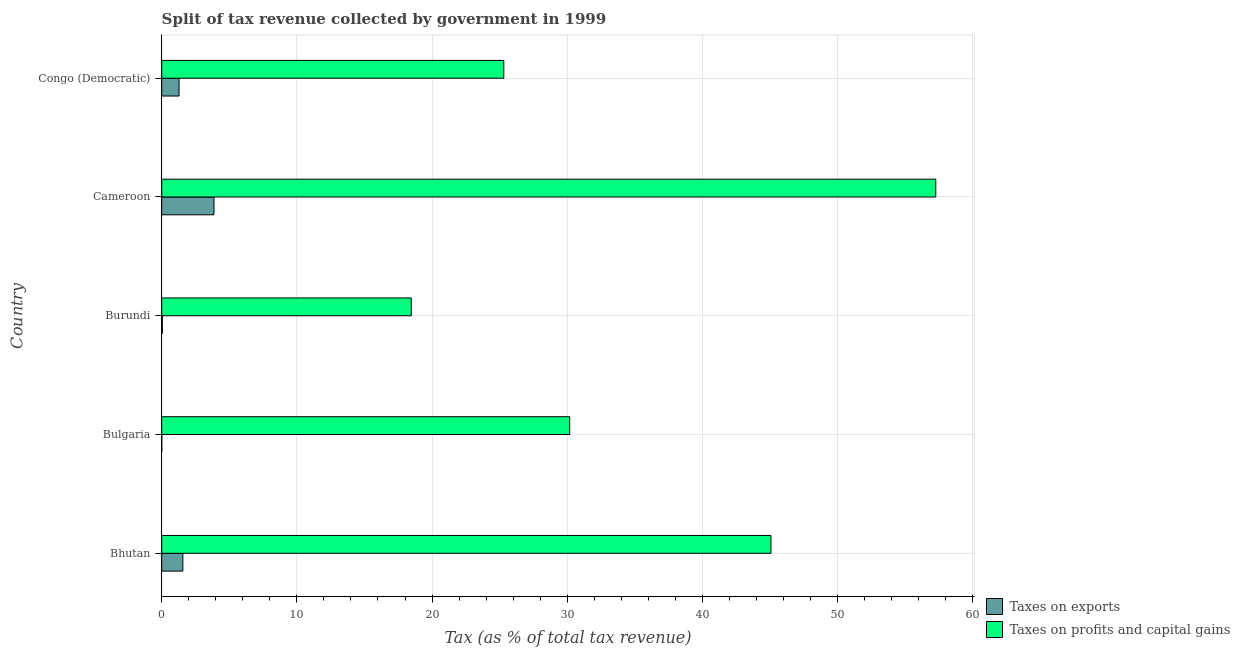How many groups of bars are there?
Provide a short and direct response. 5. Are the number of bars on each tick of the Y-axis equal?
Your response must be concise. Yes. How many bars are there on the 5th tick from the top?
Make the answer very short. 2. What is the label of the 5th group of bars from the top?
Give a very brief answer. Bhutan. What is the percentage of revenue obtained from taxes on profits and capital gains in Cameroon?
Your answer should be compact. 57.27. Across all countries, what is the maximum percentage of revenue obtained from taxes on profits and capital gains?
Make the answer very short. 57.27. Across all countries, what is the minimum percentage of revenue obtained from taxes on exports?
Ensure brevity in your answer.  0. In which country was the percentage of revenue obtained from taxes on exports maximum?
Your response must be concise. Cameroon. In which country was the percentage of revenue obtained from taxes on exports minimum?
Give a very brief answer. Bulgaria. What is the total percentage of revenue obtained from taxes on exports in the graph?
Your answer should be very brief. 6.76. What is the difference between the percentage of revenue obtained from taxes on exports in Cameroon and that in Congo (Democratic)?
Make the answer very short. 2.59. What is the difference between the percentage of revenue obtained from taxes on profits and capital gains in Congo (Democratic) and the percentage of revenue obtained from taxes on exports in Bhutan?
Offer a very short reply. 23.74. What is the average percentage of revenue obtained from taxes on profits and capital gains per country?
Give a very brief answer. 35.26. What is the difference between the percentage of revenue obtained from taxes on profits and capital gains and percentage of revenue obtained from taxes on exports in Burundi?
Give a very brief answer. 18.42. What is the ratio of the percentage of revenue obtained from taxes on profits and capital gains in Burundi to that in Cameroon?
Make the answer very short. 0.32. Is the difference between the percentage of revenue obtained from taxes on profits and capital gains in Burundi and Cameroon greater than the difference between the percentage of revenue obtained from taxes on exports in Burundi and Cameroon?
Offer a very short reply. No. What is the difference between the highest and the second highest percentage of revenue obtained from taxes on profits and capital gains?
Your answer should be very brief. 12.19. What is the difference between the highest and the lowest percentage of revenue obtained from taxes on exports?
Your response must be concise. 3.87. Is the sum of the percentage of revenue obtained from taxes on exports in Bhutan and Burundi greater than the maximum percentage of revenue obtained from taxes on profits and capital gains across all countries?
Offer a very short reply. No. What does the 1st bar from the top in Bulgaria represents?
Provide a succinct answer. Taxes on profits and capital gains. What does the 2nd bar from the bottom in Congo (Democratic) represents?
Offer a terse response. Taxes on profits and capital gains. What is the difference between two consecutive major ticks on the X-axis?
Make the answer very short. 10. Are the values on the major ticks of X-axis written in scientific E-notation?
Ensure brevity in your answer.  No. Where does the legend appear in the graph?
Your response must be concise. Bottom right. How are the legend labels stacked?
Offer a terse response. Vertical. What is the title of the graph?
Make the answer very short. Split of tax revenue collected by government in 1999. Does "Net National savings" appear as one of the legend labels in the graph?
Your answer should be very brief. No. What is the label or title of the X-axis?
Offer a very short reply. Tax (as % of total tax revenue). What is the Tax (as % of total tax revenue) of Taxes on exports in Bhutan?
Provide a short and direct response. 1.56. What is the Tax (as % of total tax revenue) in Taxes on profits and capital gains in Bhutan?
Give a very brief answer. 45.07. What is the Tax (as % of total tax revenue) in Taxes on exports in Bulgaria?
Offer a very short reply. 0. What is the Tax (as % of total tax revenue) in Taxes on profits and capital gains in Bulgaria?
Your answer should be very brief. 30.18. What is the Tax (as % of total tax revenue) of Taxes on exports in Burundi?
Your response must be concise. 0.05. What is the Tax (as % of total tax revenue) in Taxes on profits and capital gains in Burundi?
Provide a short and direct response. 18.46. What is the Tax (as % of total tax revenue) of Taxes on exports in Cameroon?
Provide a short and direct response. 3.87. What is the Tax (as % of total tax revenue) in Taxes on profits and capital gains in Cameroon?
Your answer should be very brief. 57.27. What is the Tax (as % of total tax revenue) of Taxes on exports in Congo (Democratic)?
Provide a short and direct response. 1.28. What is the Tax (as % of total tax revenue) of Taxes on profits and capital gains in Congo (Democratic)?
Offer a terse response. 25.31. Across all countries, what is the maximum Tax (as % of total tax revenue) of Taxes on exports?
Make the answer very short. 3.87. Across all countries, what is the maximum Tax (as % of total tax revenue) in Taxes on profits and capital gains?
Give a very brief answer. 57.27. Across all countries, what is the minimum Tax (as % of total tax revenue) in Taxes on exports?
Ensure brevity in your answer.  0. Across all countries, what is the minimum Tax (as % of total tax revenue) in Taxes on profits and capital gains?
Provide a short and direct response. 18.46. What is the total Tax (as % of total tax revenue) of Taxes on exports in the graph?
Offer a terse response. 6.76. What is the total Tax (as % of total tax revenue) of Taxes on profits and capital gains in the graph?
Offer a very short reply. 176.29. What is the difference between the Tax (as % of total tax revenue) of Taxes on exports in Bhutan and that in Bulgaria?
Your answer should be compact. 1.56. What is the difference between the Tax (as % of total tax revenue) in Taxes on profits and capital gains in Bhutan and that in Bulgaria?
Offer a terse response. 14.89. What is the difference between the Tax (as % of total tax revenue) in Taxes on exports in Bhutan and that in Burundi?
Your response must be concise. 1.52. What is the difference between the Tax (as % of total tax revenue) in Taxes on profits and capital gains in Bhutan and that in Burundi?
Offer a very short reply. 26.61. What is the difference between the Tax (as % of total tax revenue) in Taxes on exports in Bhutan and that in Cameroon?
Provide a short and direct response. -2.3. What is the difference between the Tax (as % of total tax revenue) of Taxes on profits and capital gains in Bhutan and that in Cameroon?
Your answer should be compact. -12.19. What is the difference between the Tax (as % of total tax revenue) in Taxes on exports in Bhutan and that in Congo (Democratic)?
Offer a very short reply. 0.28. What is the difference between the Tax (as % of total tax revenue) of Taxes on profits and capital gains in Bhutan and that in Congo (Democratic)?
Provide a short and direct response. 19.76. What is the difference between the Tax (as % of total tax revenue) in Taxes on exports in Bulgaria and that in Burundi?
Offer a very short reply. -0.04. What is the difference between the Tax (as % of total tax revenue) in Taxes on profits and capital gains in Bulgaria and that in Burundi?
Provide a succinct answer. 11.72. What is the difference between the Tax (as % of total tax revenue) in Taxes on exports in Bulgaria and that in Cameroon?
Keep it short and to the point. -3.87. What is the difference between the Tax (as % of total tax revenue) of Taxes on profits and capital gains in Bulgaria and that in Cameroon?
Offer a terse response. -27.08. What is the difference between the Tax (as % of total tax revenue) of Taxes on exports in Bulgaria and that in Congo (Democratic)?
Your response must be concise. -1.28. What is the difference between the Tax (as % of total tax revenue) in Taxes on profits and capital gains in Bulgaria and that in Congo (Democratic)?
Your response must be concise. 4.87. What is the difference between the Tax (as % of total tax revenue) in Taxes on exports in Burundi and that in Cameroon?
Offer a terse response. -3.82. What is the difference between the Tax (as % of total tax revenue) in Taxes on profits and capital gains in Burundi and that in Cameroon?
Your response must be concise. -38.8. What is the difference between the Tax (as % of total tax revenue) in Taxes on exports in Burundi and that in Congo (Democratic)?
Keep it short and to the point. -1.24. What is the difference between the Tax (as % of total tax revenue) in Taxes on profits and capital gains in Burundi and that in Congo (Democratic)?
Keep it short and to the point. -6.85. What is the difference between the Tax (as % of total tax revenue) of Taxes on exports in Cameroon and that in Congo (Democratic)?
Offer a very short reply. 2.59. What is the difference between the Tax (as % of total tax revenue) of Taxes on profits and capital gains in Cameroon and that in Congo (Democratic)?
Make the answer very short. 31.96. What is the difference between the Tax (as % of total tax revenue) of Taxes on exports in Bhutan and the Tax (as % of total tax revenue) of Taxes on profits and capital gains in Bulgaria?
Provide a short and direct response. -28.62. What is the difference between the Tax (as % of total tax revenue) of Taxes on exports in Bhutan and the Tax (as % of total tax revenue) of Taxes on profits and capital gains in Burundi?
Ensure brevity in your answer.  -16.9. What is the difference between the Tax (as % of total tax revenue) of Taxes on exports in Bhutan and the Tax (as % of total tax revenue) of Taxes on profits and capital gains in Cameroon?
Your response must be concise. -55.7. What is the difference between the Tax (as % of total tax revenue) in Taxes on exports in Bhutan and the Tax (as % of total tax revenue) in Taxes on profits and capital gains in Congo (Democratic)?
Your answer should be very brief. -23.74. What is the difference between the Tax (as % of total tax revenue) in Taxes on exports in Bulgaria and the Tax (as % of total tax revenue) in Taxes on profits and capital gains in Burundi?
Offer a very short reply. -18.46. What is the difference between the Tax (as % of total tax revenue) of Taxes on exports in Bulgaria and the Tax (as % of total tax revenue) of Taxes on profits and capital gains in Cameroon?
Make the answer very short. -57.26. What is the difference between the Tax (as % of total tax revenue) in Taxes on exports in Bulgaria and the Tax (as % of total tax revenue) in Taxes on profits and capital gains in Congo (Democratic)?
Your answer should be very brief. -25.31. What is the difference between the Tax (as % of total tax revenue) of Taxes on exports in Burundi and the Tax (as % of total tax revenue) of Taxes on profits and capital gains in Cameroon?
Ensure brevity in your answer.  -57.22. What is the difference between the Tax (as % of total tax revenue) of Taxes on exports in Burundi and the Tax (as % of total tax revenue) of Taxes on profits and capital gains in Congo (Democratic)?
Ensure brevity in your answer.  -25.26. What is the difference between the Tax (as % of total tax revenue) of Taxes on exports in Cameroon and the Tax (as % of total tax revenue) of Taxes on profits and capital gains in Congo (Democratic)?
Your answer should be compact. -21.44. What is the average Tax (as % of total tax revenue) of Taxes on exports per country?
Keep it short and to the point. 1.35. What is the average Tax (as % of total tax revenue) in Taxes on profits and capital gains per country?
Provide a short and direct response. 35.26. What is the difference between the Tax (as % of total tax revenue) in Taxes on exports and Tax (as % of total tax revenue) in Taxes on profits and capital gains in Bhutan?
Your answer should be very brief. -43.51. What is the difference between the Tax (as % of total tax revenue) of Taxes on exports and Tax (as % of total tax revenue) of Taxes on profits and capital gains in Bulgaria?
Keep it short and to the point. -30.18. What is the difference between the Tax (as % of total tax revenue) in Taxes on exports and Tax (as % of total tax revenue) in Taxes on profits and capital gains in Burundi?
Give a very brief answer. -18.42. What is the difference between the Tax (as % of total tax revenue) of Taxes on exports and Tax (as % of total tax revenue) of Taxes on profits and capital gains in Cameroon?
Your answer should be compact. -53.4. What is the difference between the Tax (as % of total tax revenue) of Taxes on exports and Tax (as % of total tax revenue) of Taxes on profits and capital gains in Congo (Democratic)?
Give a very brief answer. -24.03. What is the ratio of the Tax (as % of total tax revenue) in Taxes on exports in Bhutan to that in Bulgaria?
Your response must be concise. 980.04. What is the ratio of the Tax (as % of total tax revenue) in Taxes on profits and capital gains in Bhutan to that in Bulgaria?
Offer a very short reply. 1.49. What is the ratio of the Tax (as % of total tax revenue) in Taxes on exports in Bhutan to that in Burundi?
Your answer should be compact. 34.11. What is the ratio of the Tax (as % of total tax revenue) of Taxes on profits and capital gains in Bhutan to that in Burundi?
Give a very brief answer. 2.44. What is the ratio of the Tax (as % of total tax revenue) in Taxes on exports in Bhutan to that in Cameroon?
Your answer should be very brief. 0.4. What is the ratio of the Tax (as % of total tax revenue) of Taxes on profits and capital gains in Bhutan to that in Cameroon?
Your answer should be compact. 0.79. What is the ratio of the Tax (as % of total tax revenue) in Taxes on exports in Bhutan to that in Congo (Democratic)?
Offer a very short reply. 1.22. What is the ratio of the Tax (as % of total tax revenue) of Taxes on profits and capital gains in Bhutan to that in Congo (Democratic)?
Ensure brevity in your answer.  1.78. What is the ratio of the Tax (as % of total tax revenue) of Taxes on exports in Bulgaria to that in Burundi?
Provide a short and direct response. 0.03. What is the ratio of the Tax (as % of total tax revenue) in Taxes on profits and capital gains in Bulgaria to that in Burundi?
Provide a short and direct response. 1.63. What is the ratio of the Tax (as % of total tax revenue) of Taxes on exports in Bulgaria to that in Cameroon?
Give a very brief answer. 0. What is the ratio of the Tax (as % of total tax revenue) in Taxes on profits and capital gains in Bulgaria to that in Cameroon?
Provide a short and direct response. 0.53. What is the ratio of the Tax (as % of total tax revenue) in Taxes on exports in Bulgaria to that in Congo (Democratic)?
Your answer should be very brief. 0. What is the ratio of the Tax (as % of total tax revenue) of Taxes on profits and capital gains in Bulgaria to that in Congo (Democratic)?
Your answer should be compact. 1.19. What is the ratio of the Tax (as % of total tax revenue) of Taxes on exports in Burundi to that in Cameroon?
Offer a very short reply. 0.01. What is the ratio of the Tax (as % of total tax revenue) of Taxes on profits and capital gains in Burundi to that in Cameroon?
Keep it short and to the point. 0.32. What is the ratio of the Tax (as % of total tax revenue) in Taxes on exports in Burundi to that in Congo (Democratic)?
Your answer should be compact. 0.04. What is the ratio of the Tax (as % of total tax revenue) of Taxes on profits and capital gains in Burundi to that in Congo (Democratic)?
Keep it short and to the point. 0.73. What is the ratio of the Tax (as % of total tax revenue) in Taxes on exports in Cameroon to that in Congo (Democratic)?
Ensure brevity in your answer.  3.02. What is the ratio of the Tax (as % of total tax revenue) of Taxes on profits and capital gains in Cameroon to that in Congo (Democratic)?
Your response must be concise. 2.26. What is the difference between the highest and the second highest Tax (as % of total tax revenue) of Taxes on exports?
Provide a succinct answer. 2.3. What is the difference between the highest and the second highest Tax (as % of total tax revenue) of Taxes on profits and capital gains?
Offer a terse response. 12.19. What is the difference between the highest and the lowest Tax (as % of total tax revenue) of Taxes on exports?
Your answer should be very brief. 3.87. What is the difference between the highest and the lowest Tax (as % of total tax revenue) in Taxes on profits and capital gains?
Your response must be concise. 38.8. 